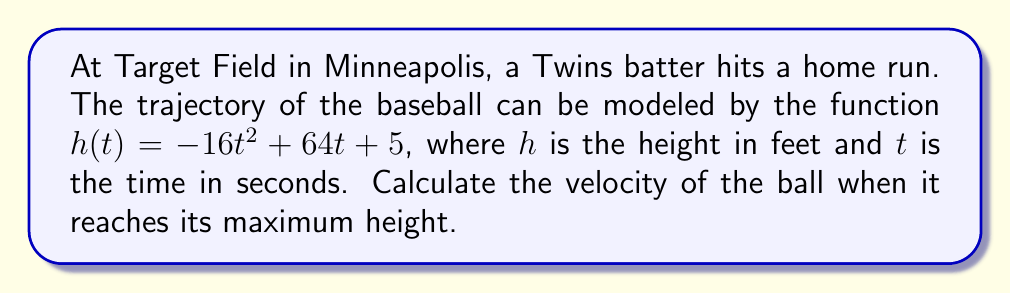Help me with this question. To solve this problem, we'll follow these steps:

1) First, we need to find when the ball reaches its maximum height. This occurs when the velocity is zero.

2) The velocity function is the first derivative of the position function:
   $$v(t) = h'(t) = -32t + 64$$

3) Set the velocity to zero and solve for t:
   $$-32t + 64 = 0$$
   $$-32t = -64$$
   $$t = 2$$

4) Now that we know the ball reaches its maximum height at t = 2 seconds, we need to find the velocity just before or after this point.

5) To do this, we'll use the second derivative, which represents acceleration:
   $$a(t) = v'(t) = h''(t) = -32$$

6) The acceleration is constant at -32 ft/s², which is the acceleration due to gravity.

7) At the maximum height, the velocity instantaneously becomes zero, but immediately before and after, it's approaching or leaving zero. We can calculate this using the limit of the velocity as t approaches 2:

   $$\lim_{t \to 2} v(t) = \lim_{t \to 2} (-32t + 64) = -32(2) + 64 = 0$$

Therefore, the velocity at the maximum height is 0 ft/s.
Answer: 0 ft/s 